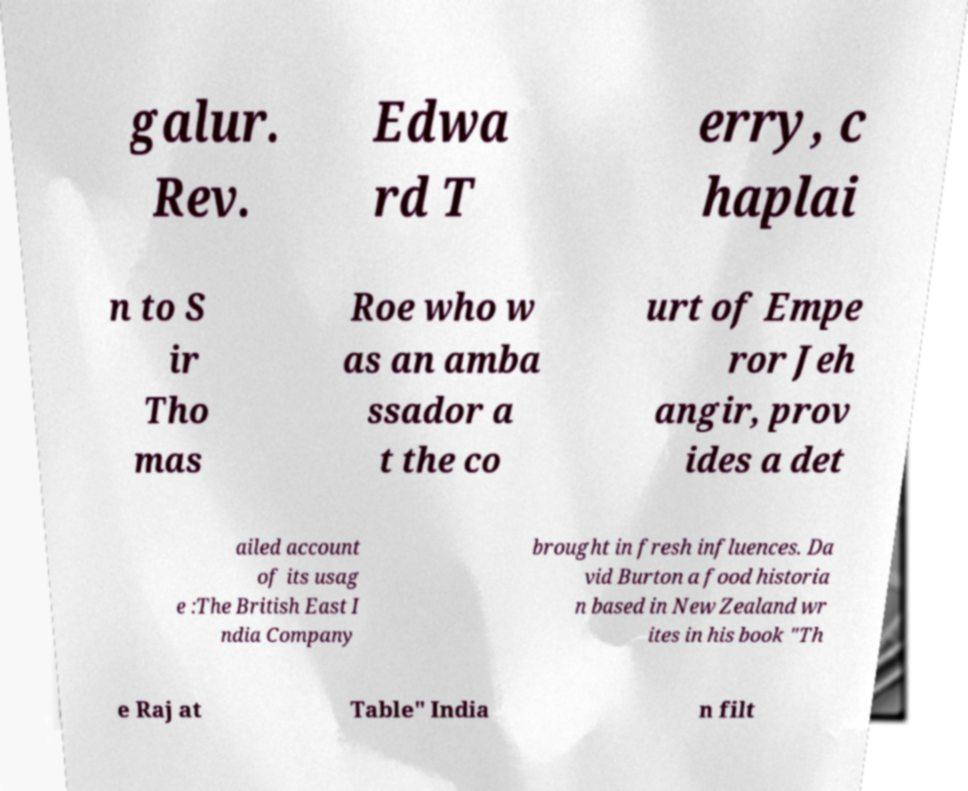Could you assist in decoding the text presented in this image and type it out clearly? galur. Rev. Edwa rd T erry, c haplai n to S ir Tho mas Roe who w as an amba ssador a t the co urt of Empe ror Jeh angir, prov ides a det ailed account of its usag e :The British East I ndia Company brought in fresh influences. Da vid Burton a food historia n based in New Zealand wr ites in his book "Th e Raj at Table" India n filt 